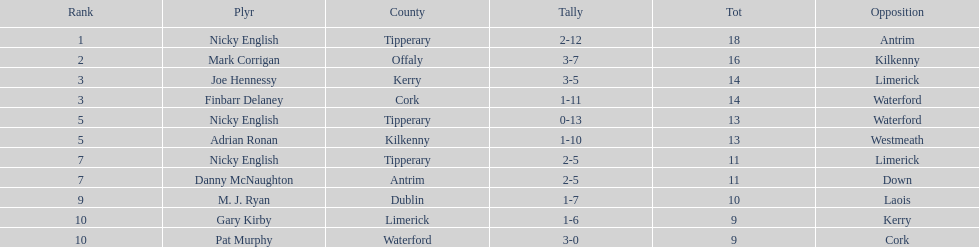How many people are on the list? 9. 